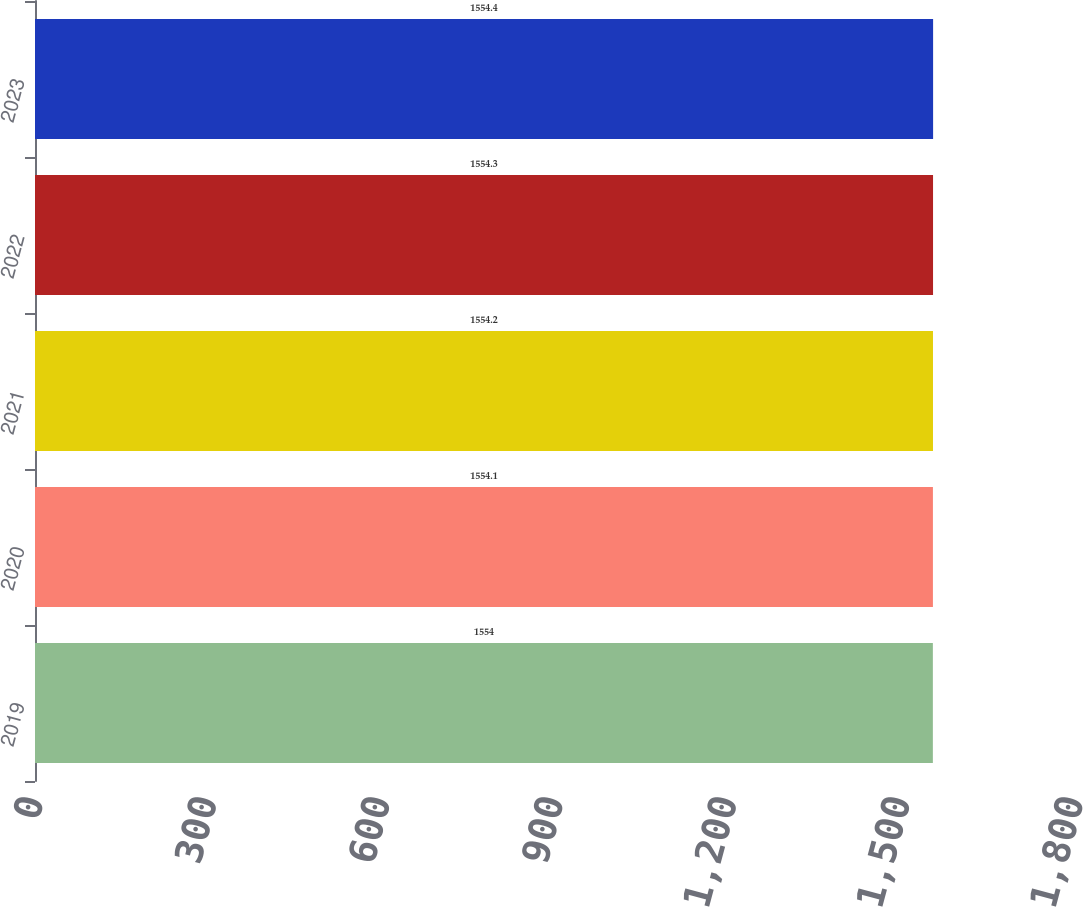<chart> <loc_0><loc_0><loc_500><loc_500><bar_chart><fcel>2019<fcel>2020<fcel>2021<fcel>2022<fcel>2023<nl><fcel>1554<fcel>1554.1<fcel>1554.2<fcel>1554.3<fcel>1554.4<nl></chart> 